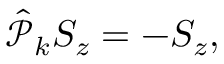Convert formula to latex. <formula><loc_0><loc_0><loc_500><loc_500>\begin{array} { r } { \hat { \mathcal { P } } _ { k } S _ { z } = - S _ { z } , } \end{array}</formula> 